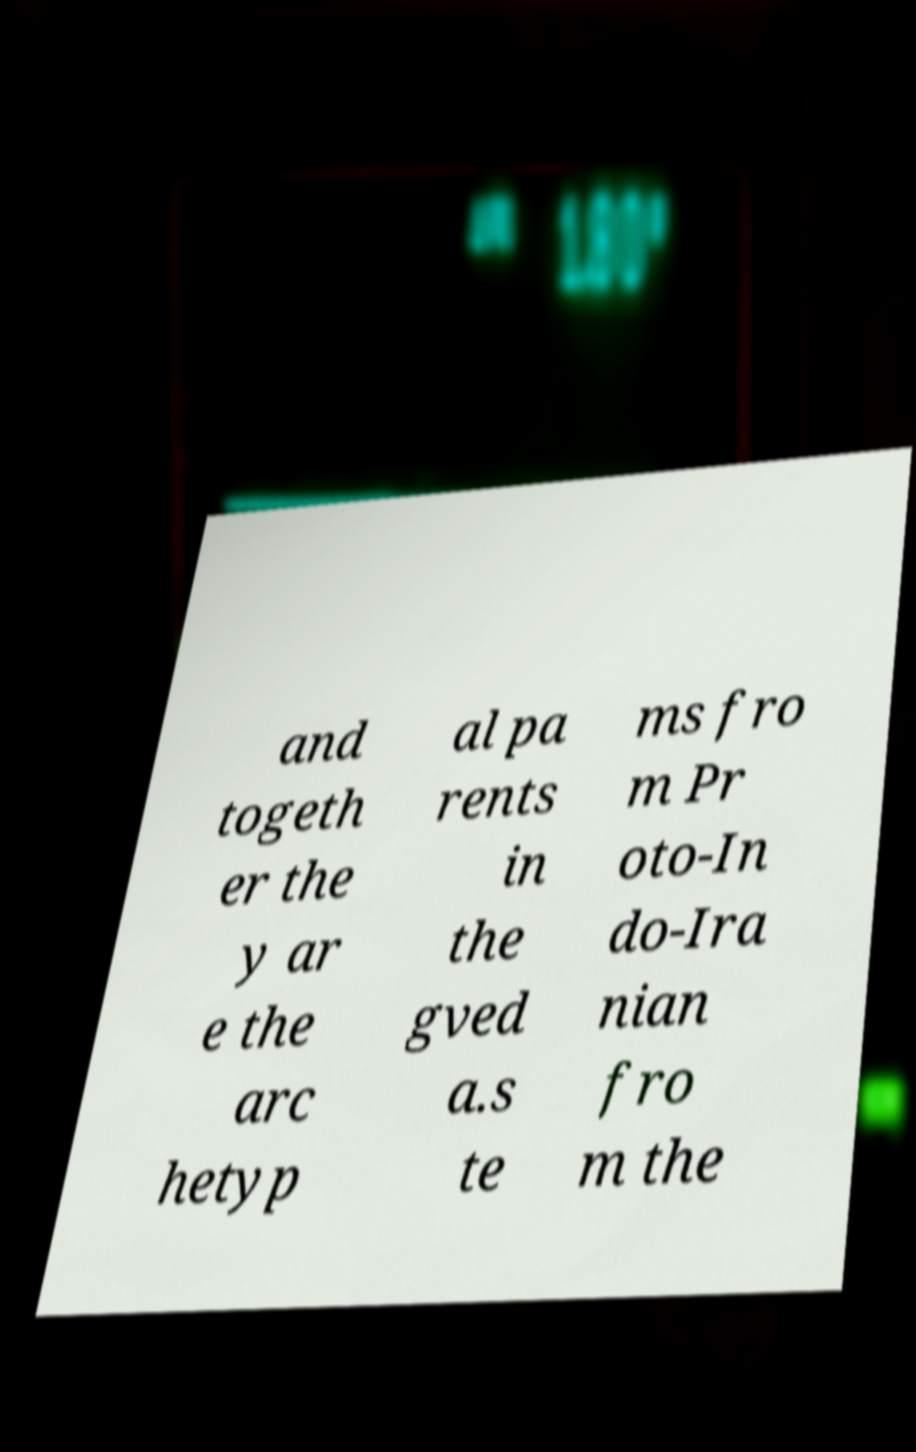Could you extract and type out the text from this image? and togeth er the y ar e the arc hetyp al pa rents in the gved a.s te ms fro m Pr oto-In do-Ira nian fro m the 